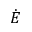Convert formula to latex. <formula><loc_0><loc_0><loc_500><loc_500>\dot { E }</formula> 